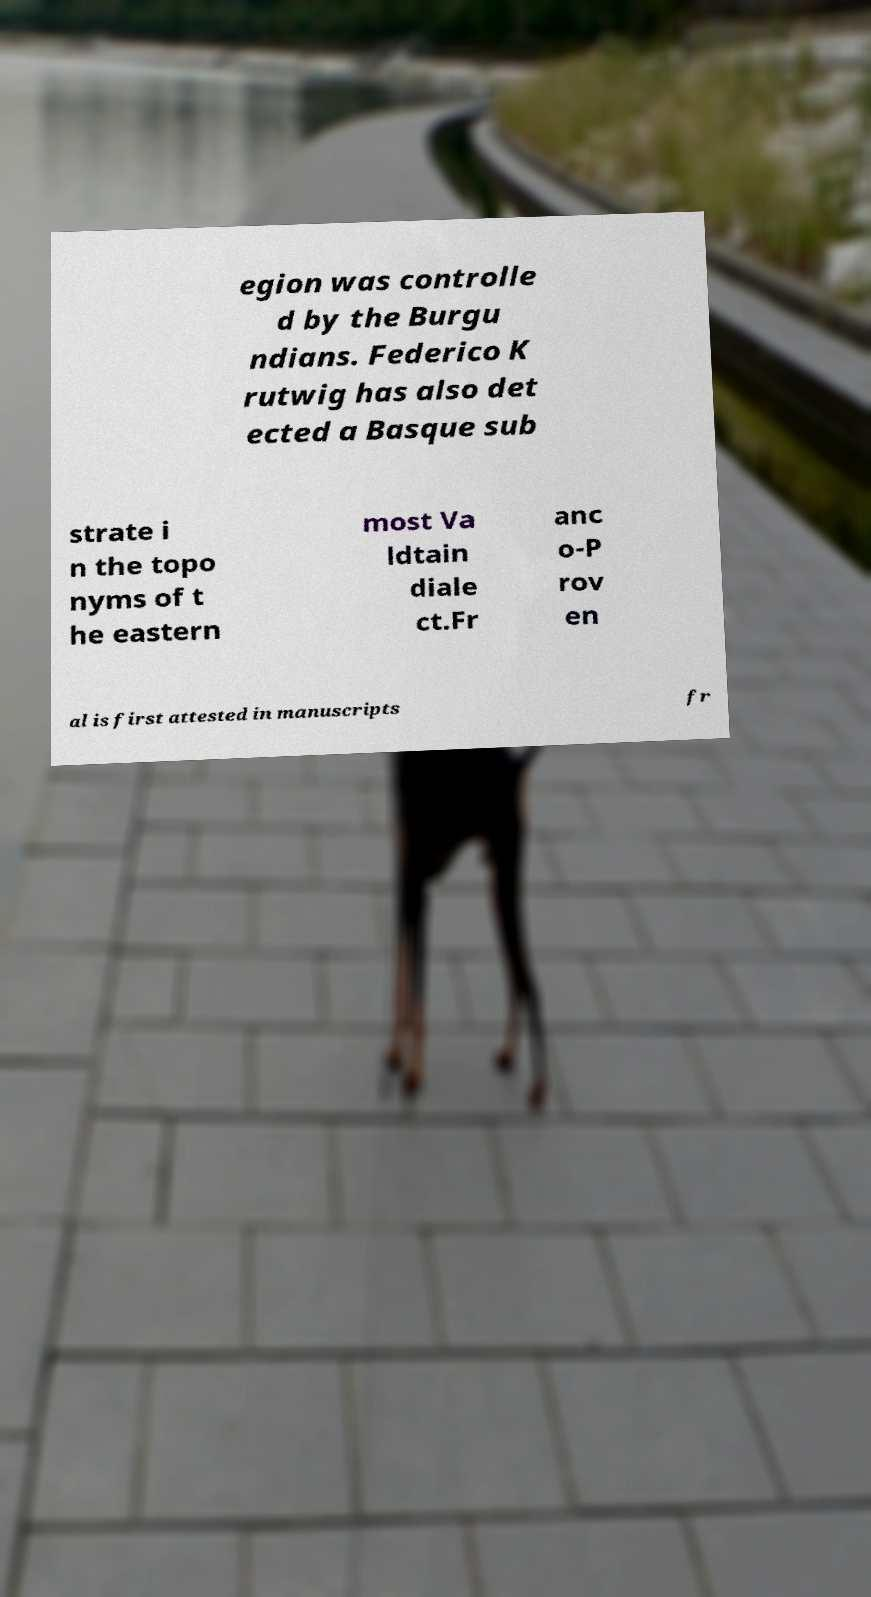What messages or text are displayed in this image? I need them in a readable, typed format. egion was controlle d by the Burgu ndians. Federico K rutwig has also det ected a Basque sub strate i n the topo nyms of t he eastern most Va ldtain diale ct.Fr anc o-P rov en al is first attested in manuscripts fr 